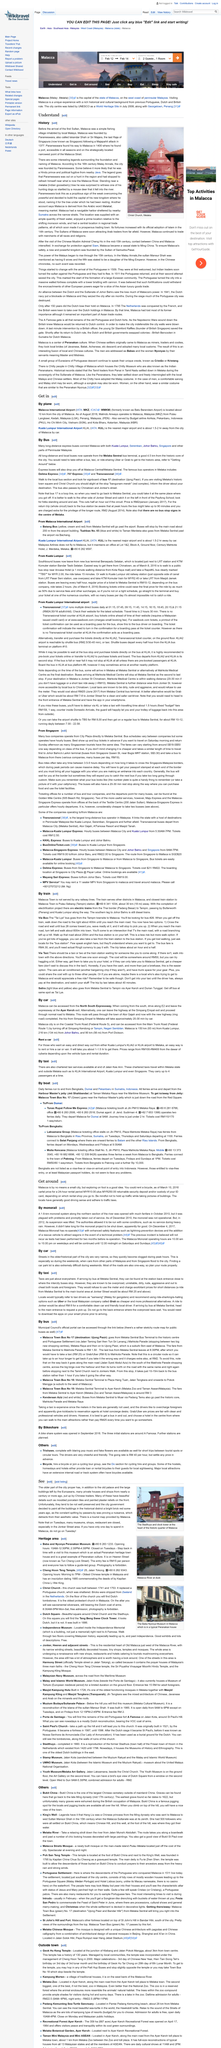Point out several critical features in this image. The city of Malacca is located closest to Kuala Lumpur International airport, which is a major airport that is approximately 1.5 to 2 hours away from the city of Malacca by car. The Melaka Sentral bus terminal serves as the central hub for both long-distance and local buses. Situated approximately 4.5 kilometers from the historic core of the city, it offers convenient access to travelers seeking to reach their desired destination. Malacca International Airport, previously known as Batu Berendam Airport, is located in the state of Malacca, Malaysia. 